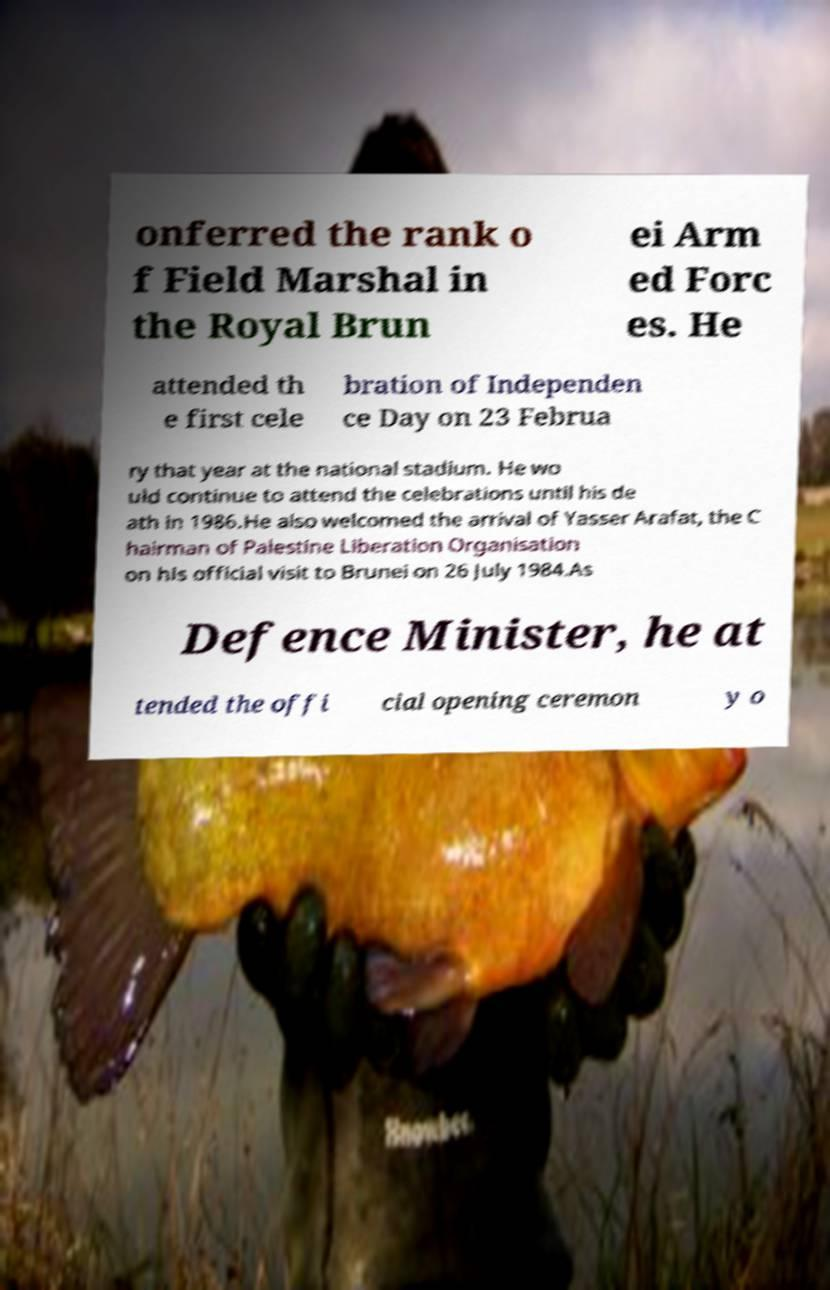There's text embedded in this image that I need extracted. Can you transcribe it verbatim? onferred the rank o f Field Marshal in the Royal Brun ei Arm ed Forc es. He attended th e first cele bration of Independen ce Day on 23 Februa ry that year at the national stadium. He wo uld continue to attend the celebrations until his de ath in 1986.He also welcomed the arrival of Yasser Arafat, the C hairman of Palestine Liberation Organisation on his official visit to Brunei on 26 July 1984.As Defence Minister, he at tended the offi cial opening ceremon y o 